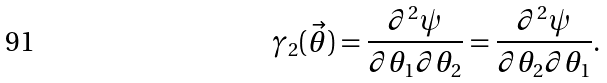<formula> <loc_0><loc_0><loc_500><loc_500>\gamma _ { 2 } ( \vec { \theta } ) = \frac { \partial ^ { 2 } \psi } { \partial \theta _ { 1 } \partial \theta _ { 2 } } = \frac { \partial ^ { 2 } \psi } { \partial \theta _ { 2 } \partial \theta _ { 1 } } .</formula> 